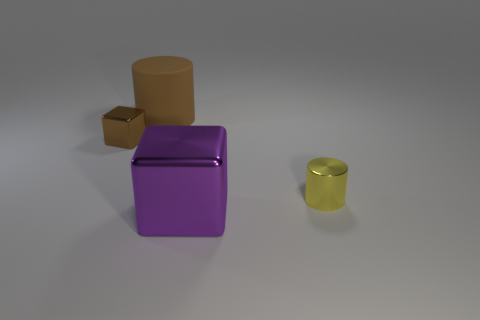Add 4 purple matte cubes. How many objects exist? 8 Add 4 tiny metallic objects. How many tiny metallic objects are left? 6 Add 1 brown cubes. How many brown cubes exist? 2 Subtract 1 brown blocks. How many objects are left? 3 Subtract all gray cylinders. Subtract all red cubes. How many cylinders are left? 2 Subtract all small green metal things. Subtract all large brown cylinders. How many objects are left? 3 